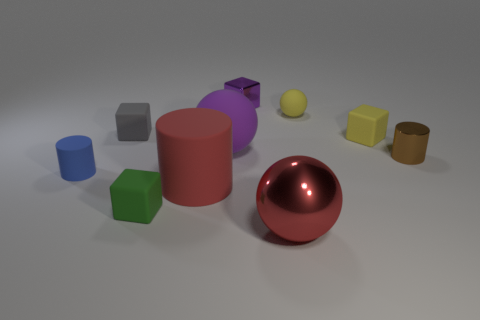What time of day does the lighting in the image suggest? The lighting in the image is quite neutral and doesn't strongly suggest any particular time of day as it might be a studio lighting setup; the shadows are soft and the light appears to be diffused evenly across the scene. 